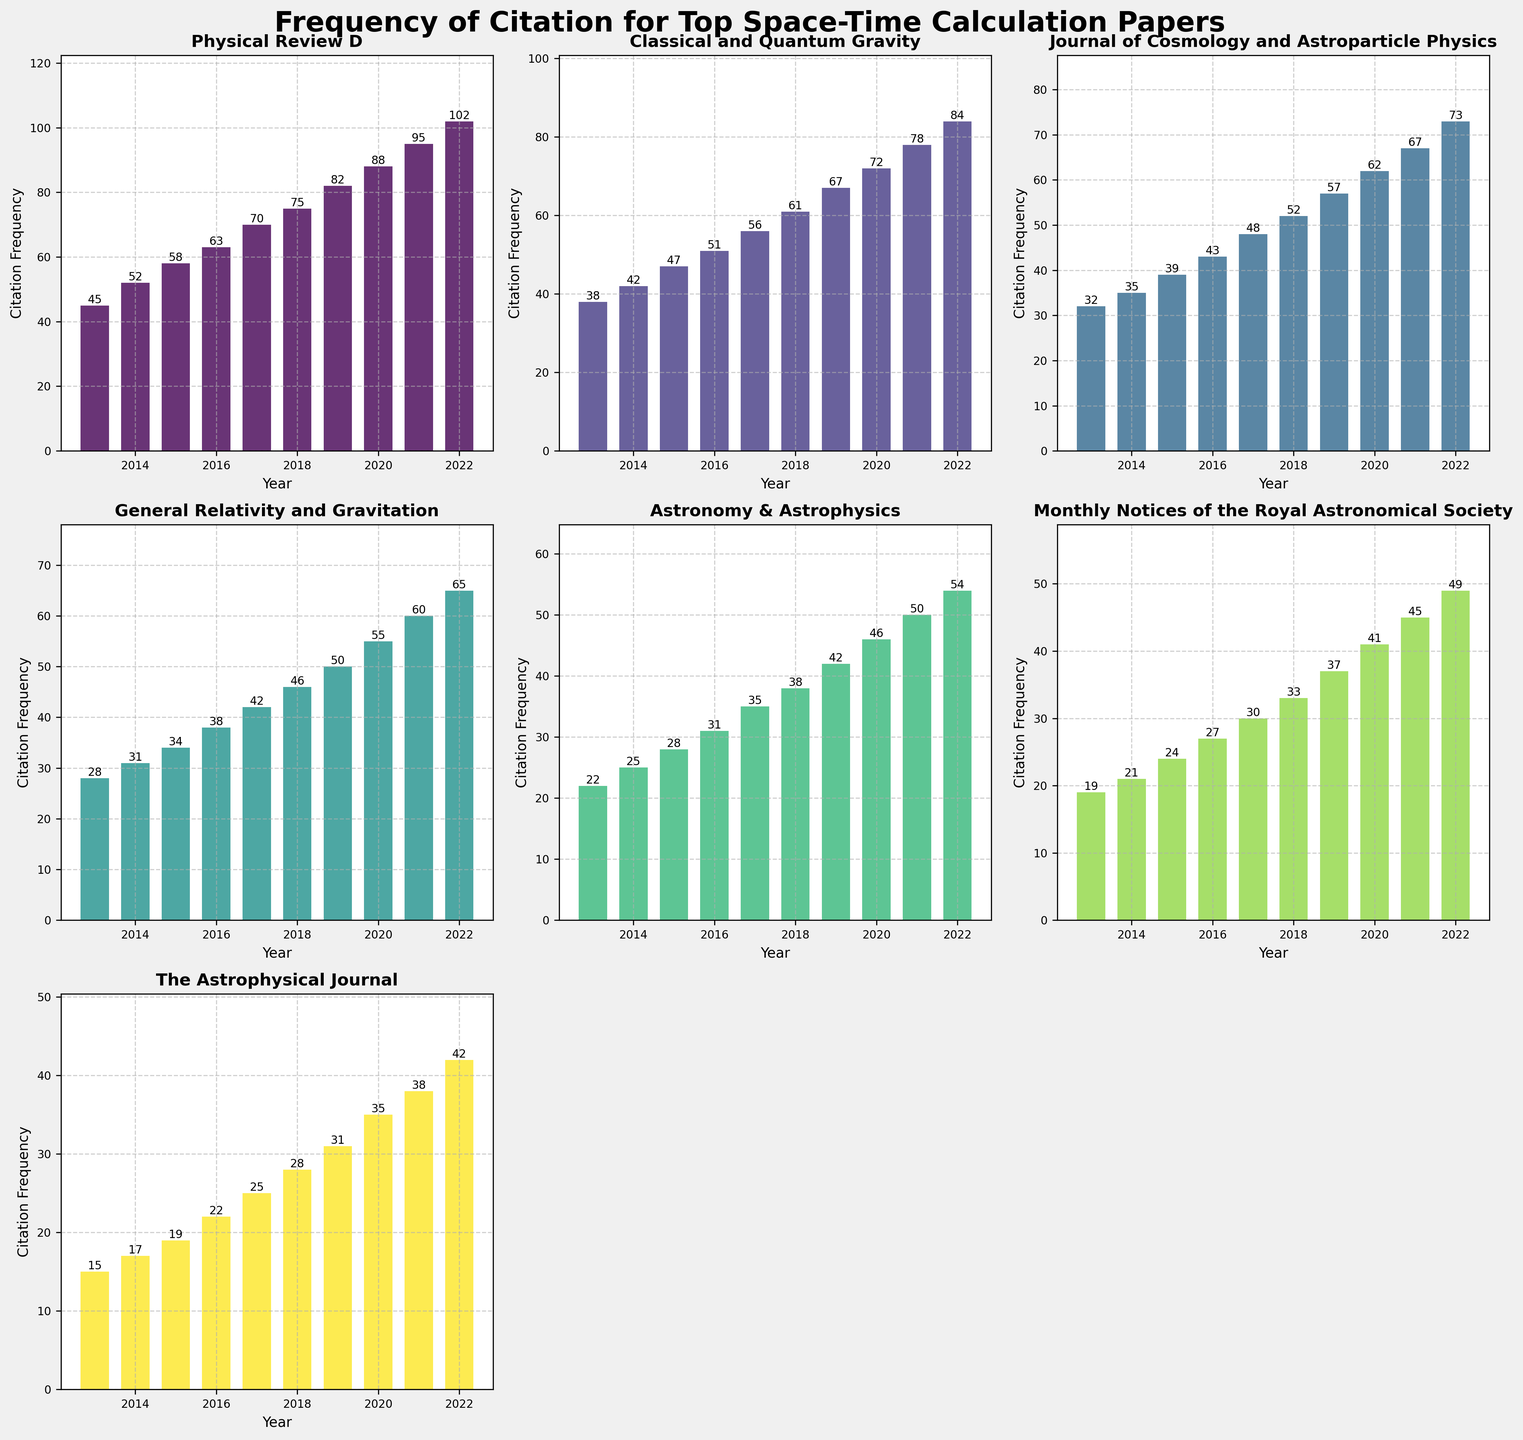What is the title of the figure? The title of the figure is located at the top center of the plot. It reads 'Frequency of Citation for Top Space-Time Calculation Papers', which helps indicate the overall theme of the visualized data.
Answer: Frequency of Citation for Top Space-Time Calculation Papers How many journals are represented in the figure? To determine the number of journals, count the titles of the subplots. Each subplot represents a different journal, and there are 7 subplots in total.
Answer: 7 Which journal had the highest citation frequency in 2022? To find the journal with the highest citation frequency in 2022, look for the tallest bar in 2022 across all subplots. Physical Review D has the highest bar in 2022.
Answer: Physical Review D What is the average citation frequency for Classical and Quantum Gravity from 2013 to 2022? Sum the citation frequencies for Classical and Quantum Gravity for each year from 2013 to 2022, then divide by the number of years (10). Sum = 38 + 42 + 47 + 51 + 56 + 61 + 67 + 72 + 78 + 84 = 596; average = 596 / 10 = 59.6.
Answer: 59.6 Which journal had the least citation growth from 2013 to 2022? To determine the least citation growth, subtract the 2013 citation from the 2022 citation for each journal and compare the differences. The Astrophysical Journal had the smallest growth (42 - 15 = 27).
Answer: The Astrophysical Journal Compare the citation frequencies of Astronomy & Astrophysics and General Relativity and Gravitation in 2020. Which one was higher? Look at the bars for 2020 in both subplots. Astronomy & Astrophysics had 46 citations, while General Relativity and Gravitation had 55 citations. Hence, General Relativity and Gravitation had higher citations in 2020.
Answer: General Relativity and Gravitation What is the total sum of citation frequencies for Journal of Cosmology and Astroparticle Physics across all given years? Add all the citation frequencies from 2013 to 2022 for Journal of Cosmology and Astroparticle Physics. Sum = 32 + 35 + 39 + 43 + 48 + 52 + 57 + 62 + 67 + 73 = 508.
Answer: 508 Which year had the highest total citation frequency across all journals? Sum the citation frequencies for all journals in each year and find the year with the maximum sum. The sums are as follows:
- 2013: 199
- 2014: 223
- 2015: 253
- 2016: 283
- 2017: 324
- 2018: 333
- 2019: 366
- 2020: 390
- 2021: 420
- 2022: 462. Hence, 2022 had the highest total citation frequency.
Answer: 2022 Describe the trend of citation frequency for Monthly Notices of the Royal Astronomical Society over the years. Observe the bar heights over the years for Monthly Notices of the Royal Astronomical Society, which shows an increasing trend from 2013 to 2022. It starts at 19 in 2013 and rises steadily to 49 in 2022.
Answer: Increasing trend Which journal had exactly 50 citations in any given year, and in which year was it? Look for a bar with the height of 50 in the subplots. General Relativity and Gravitation had 50 citations in 2019.
Answer: General Relativity and Gravitation in 2019 